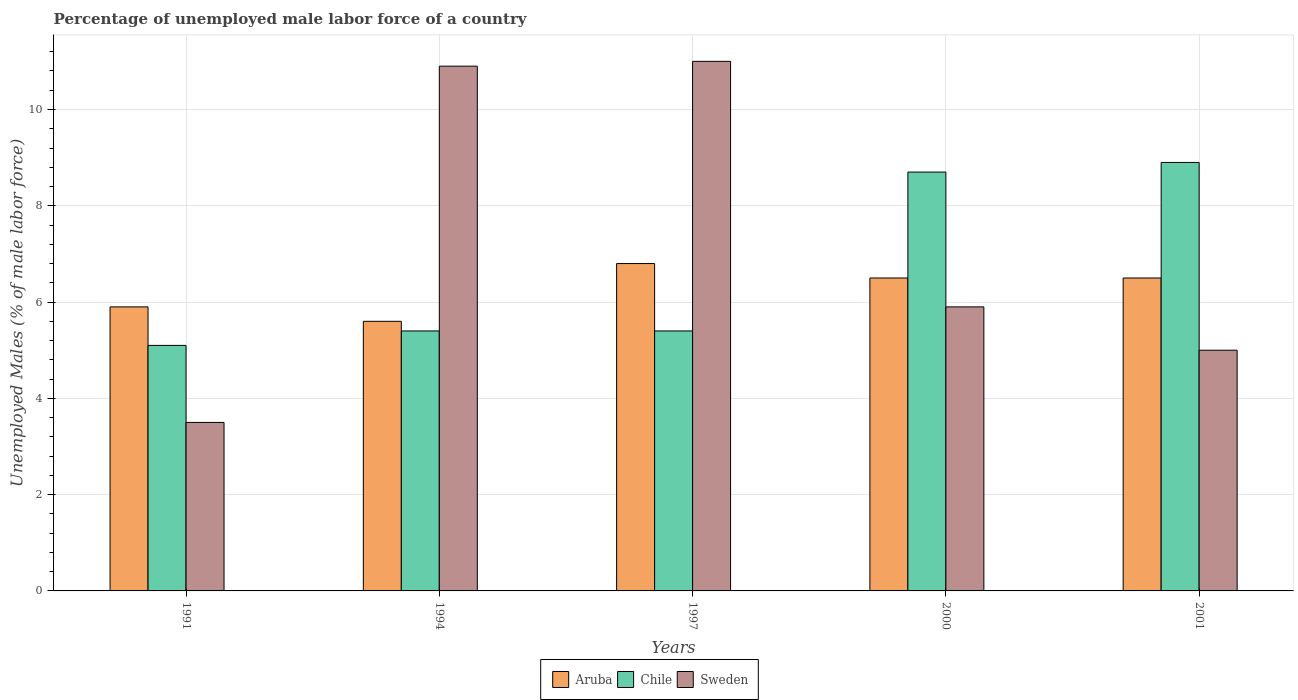How many different coloured bars are there?
Provide a succinct answer. 3. How many groups of bars are there?
Give a very brief answer. 5. Are the number of bars per tick equal to the number of legend labels?
Offer a terse response. Yes. How many bars are there on the 1st tick from the right?
Keep it short and to the point. 3. What is the percentage of unemployed male labor force in Chile in 2000?
Ensure brevity in your answer.  8.7. Across all years, what is the maximum percentage of unemployed male labor force in Sweden?
Your answer should be compact. 11. Across all years, what is the minimum percentage of unemployed male labor force in Chile?
Give a very brief answer. 5.1. What is the total percentage of unemployed male labor force in Aruba in the graph?
Provide a succinct answer. 31.3. What is the difference between the percentage of unemployed male labor force in Aruba in 1997 and that in 2001?
Your response must be concise. 0.3. What is the difference between the percentage of unemployed male labor force in Aruba in 1997 and the percentage of unemployed male labor force in Sweden in 1994?
Offer a very short reply. -4.1. What is the average percentage of unemployed male labor force in Aruba per year?
Offer a terse response. 6.26. In the year 2001, what is the difference between the percentage of unemployed male labor force in Aruba and percentage of unemployed male labor force in Chile?
Provide a short and direct response. -2.4. What is the ratio of the percentage of unemployed male labor force in Chile in 1991 to that in 1994?
Offer a very short reply. 0.94. Is the percentage of unemployed male labor force in Aruba in 1994 less than that in 2000?
Your response must be concise. Yes. Is the difference between the percentage of unemployed male labor force in Aruba in 1991 and 1994 greater than the difference between the percentage of unemployed male labor force in Chile in 1991 and 1994?
Make the answer very short. Yes. What is the difference between the highest and the second highest percentage of unemployed male labor force in Aruba?
Keep it short and to the point. 0.3. What is the difference between the highest and the lowest percentage of unemployed male labor force in Aruba?
Your response must be concise. 1.2. What does the 1st bar from the left in 1994 represents?
Provide a short and direct response. Aruba. What does the 3rd bar from the right in 1991 represents?
Your answer should be very brief. Aruba. Does the graph contain any zero values?
Offer a terse response. No. Where does the legend appear in the graph?
Your response must be concise. Bottom center. How many legend labels are there?
Offer a terse response. 3. What is the title of the graph?
Make the answer very short. Percentage of unemployed male labor force of a country. Does "Lower middle income" appear as one of the legend labels in the graph?
Make the answer very short. No. What is the label or title of the Y-axis?
Your answer should be compact. Unemployed Males (% of male labor force). What is the Unemployed Males (% of male labor force) of Aruba in 1991?
Make the answer very short. 5.9. What is the Unemployed Males (% of male labor force) of Chile in 1991?
Ensure brevity in your answer.  5.1. What is the Unemployed Males (% of male labor force) of Aruba in 1994?
Keep it short and to the point. 5.6. What is the Unemployed Males (% of male labor force) in Chile in 1994?
Provide a succinct answer. 5.4. What is the Unemployed Males (% of male labor force) of Sweden in 1994?
Your answer should be very brief. 10.9. What is the Unemployed Males (% of male labor force) in Aruba in 1997?
Ensure brevity in your answer.  6.8. What is the Unemployed Males (% of male labor force) of Chile in 1997?
Provide a short and direct response. 5.4. What is the Unemployed Males (% of male labor force) of Aruba in 2000?
Your response must be concise. 6.5. What is the Unemployed Males (% of male labor force) of Chile in 2000?
Offer a very short reply. 8.7. What is the Unemployed Males (% of male labor force) of Sweden in 2000?
Offer a very short reply. 5.9. What is the Unemployed Males (% of male labor force) of Chile in 2001?
Provide a short and direct response. 8.9. Across all years, what is the maximum Unemployed Males (% of male labor force) of Aruba?
Your answer should be compact. 6.8. Across all years, what is the maximum Unemployed Males (% of male labor force) of Chile?
Your answer should be very brief. 8.9. Across all years, what is the maximum Unemployed Males (% of male labor force) in Sweden?
Offer a terse response. 11. Across all years, what is the minimum Unemployed Males (% of male labor force) of Aruba?
Offer a terse response. 5.6. Across all years, what is the minimum Unemployed Males (% of male labor force) in Chile?
Your answer should be compact. 5.1. Across all years, what is the minimum Unemployed Males (% of male labor force) of Sweden?
Make the answer very short. 3.5. What is the total Unemployed Males (% of male labor force) of Aruba in the graph?
Your answer should be very brief. 31.3. What is the total Unemployed Males (% of male labor force) in Chile in the graph?
Make the answer very short. 33.5. What is the total Unemployed Males (% of male labor force) of Sweden in the graph?
Your answer should be very brief. 36.3. What is the difference between the Unemployed Males (% of male labor force) of Aruba in 1991 and that in 1994?
Your response must be concise. 0.3. What is the difference between the Unemployed Males (% of male labor force) in Chile in 1991 and that in 1994?
Provide a succinct answer. -0.3. What is the difference between the Unemployed Males (% of male labor force) of Sweden in 1991 and that in 1994?
Offer a very short reply. -7.4. What is the difference between the Unemployed Males (% of male labor force) of Sweden in 1991 and that in 1997?
Your response must be concise. -7.5. What is the difference between the Unemployed Males (% of male labor force) in Chile in 1991 and that in 2000?
Your answer should be very brief. -3.6. What is the difference between the Unemployed Males (% of male labor force) in Sweden in 1991 and that in 2000?
Ensure brevity in your answer.  -2.4. What is the difference between the Unemployed Males (% of male labor force) of Aruba in 1994 and that in 1997?
Offer a very short reply. -1.2. What is the difference between the Unemployed Males (% of male labor force) of Chile in 1994 and that in 2000?
Give a very brief answer. -3.3. What is the difference between the Unemployed Males (% of male labor force) in Sweden in 1994 and that in 2000?
Offer a terse response. 5. What is the difference between the Unemployed Males (% of male labor force) in Aruba in 1994 and that in 2001?
Provide a succinct answer. -0.9. What is the difference between the Unemployed Males (% of male labor force) of Chile in 1994 and that in 2001?
Ensure brevity in your answer.  -3.5. What is the difference between the Unemployed Males (% of male labor force) in Sweden in 1994 and that in 2001?
Make the answer very short. 5.9. What is the difference between the Unemployed Males (% of male labor force) in Chile in 1997 and that in 2000?
Ensure brevity in your answer.  -3.3. What is the difference between the Unemployed Males (% of male labor force) of Sweden in 1997 and that in 2000?
Your response must be concise. 5.1. What is the difference between the Unemployed Males (% of male labor force) in Aruba in 1997 and that in 2001?
Provide a succinct answer. 0.3. What is the difference between the Unemployed Males (% of male labor force) of Chile in 1997 and that in 2001?
Offer a terse response. -3.5. What is the difference between the Unemployed Males (% of male labor force) of Sweden in 1997 and that in 2001?
Provide a succinct answer. 6. What is the difference between the Unemployed Males (% of male labor force) of Aruba in 2000 and that in 2001?
Your answer should be compact. 0. What is the difference between the Unemployed Males (% of male labor force) in Aruba in 1991 and the Unemployed Males (% of male labor force) in Sweden in 1994?
Provide a succinct answer. -5. What is the difference between the Unemployed Males (% of male labor force) of Chile in 1991 and the Unemployed Males (% of male labor force) of Sweden in 1994?
Provide a succinct answer. -5.8. What is the difference between the Unemployed Males (% of male labor force) in Aruba in 1991 and the Unemployed Males (% of male labor force) in Chile in 1997?
Offer a very short reply. 0.5. What is the difference between the Unemployed Males (% of male labor force) of Chile in 1991 and the Unemployed Males (% of male labor force) of Sweden in 1997?
Your answer should be compact. -5.9. What is the difference between the Unemployed Males (% of male labor force) in Aruba in 1991 and the Unemployed Males (% of male labor force) in Sweden in 2001?
Provide a succinct answer. 0.9. What is the difference between the Unemployed Males (% of male labor force) of Chile in 1991 and the Unemployed Males (% of male labor force) of Sweden in 2001?
Provide a succinct answer. 0.1. What is the difference between the Unemployed Males (% of male labor force) in Aruba in 1994 and the Unemployed Males (% of male labor force) in Chile in 1997?
Keep it short and to the point. 0.2. What is the difference between the Unemployed Males (% of male labor force) in Aruba in 1994 and the Unemployed Males (% of male labor force) in Sweden in 1997?
Make the answer very short. -5.4. What is the difference between the Unemployed Males (% of male labor force) in Chile in 1994 and the Unemployed Males (% of male labor force) in Sweden in 1997?
Offer a very short reply. -5.6. What is the difference between the Unemployed Males (% of male labor force) of Aruba in 1994 and the Unemployed Males (% of male labor force) of Chile in 2000?
Your answer should be very brief. -3.1. What is the difference between the Unemployed Males (% of male labor force) of Chile in 1994 and the Unemployed Males (% of male labor force) of Sweden in 2000?
Ensure brevity in your answer.  -0.5. What is the difference between the Unemployed Males (% of male labor force) in Aruba in 1994 and the Unemployed Males (% of male labor force) in Chile in 2001?
Ensure brevity in your answer.  -3.3. What is the difference between the Unemployed Males (% of male labor force) of Chile in 1994 and the Unemployed Males (% of male labor force) of Sweden in 2001?
Offer a very short reply. 0.4. What is the difference between the Unemployed Males (% of male labor force) in Aruba in 1997 and the Unemployed Males (% of male labor force) in Sweden in 2000?
Offer a very short reply. 0.9. What is the difference between the Unemployed Males (% of male labor force) of Aruba in 1997 and the Unemployed Males (% of male labor force) of Sweden in 2001?
Your answer should be compact. 1.8. What is the difference between the Unemployed Males (% of male labor force) in Aruba in 2000 and the Unemployed Males (% of male labor force) in Chile in 2001?
Ensure brevity in your answer.  -2.4. What is the difference between the Unemployed Males (% of male labor force) of Aruba in 2000 and the Unemployed Males (% of male labor force) of Sweden in 2001?
Your answer should be very brief. 1.5. What is the difference between the Unemployed Males (% of male labor force) of Chile in 2000 and the Unemployed Males (% of male labor force) of Sweden in 2001?
Provide a succinct answer. 3.7. What is the average Unemployed Males (% of male labor force) in Aruba per year?
Offer a terse response. 6.26. What is the average Unemployed Males (% of male labor force) of Chile per year?
Your response must be concise. 6.7. What is the average Unemployed Males (% of male labor force) in Sweden per year?
Make the answer very short. 7.26. In the year 1991, what is the difference between the Unemployed Males (% of male labor force) in Aruba and Unemployed Males (% of male labor force) in Sweden?
Offer a very short reply. 2.4. In the year 1994, what is the difference between the Unemployed Males (% of male labor force) in Aruba and Unemployed Males (% of male labor force) in Sweden?
Provide a succinct answer. -5.3. In the year 1997, what is the difference between the Unemployed Males (% of male labor force) in Aruba and Unemployed Males (% of male labor force) in Sweden?
Offer a terse response. -4.2. In the year 2000, what is the difference between the Unemployed Males (% of male labor force) in Aruba and Unemployed Males (% of male labor force) in Sweden?
Provide a short and direct response. 0.6. In the year 2000, what is the difference between the Unemployed Males (% of male labor force) in Chile and Unemployed Males (% of male labor force) in Sweden?
Provide a short and direct response. 2.8. In the year 2001, what is the difference between the Unemployed Males (% of male labor force) in Aruba and Unemployed Males (% of male labor force) in Chile?
Your response must be concise. -2.4. In the year 2001, what is the difference between the Unemployed Males (% of male labor force) of Aruba and Unemployed Males (% of male labor force) of Sweden?
Provide a short and direct response. 1.5. What is the ratio of the Unemployed Males (% of male labor force) in Aruba in 1991 to that in 1994?
Your response must be concise. 1.05. What is the ratio of the Unemployed Males (% of male labor force) in Sweden in 1991 to that in 1994?
Provide a succinct answer. 0.32. What is the ratio of the Unemployed Males (% of male labor force) in Aruba in 1991 to that in 1997?
Give a very brief answer. 0.87. What is the ratio of the Unemployed Males (% of male labor force) in Sweden in 1991 to that in 1997?
Keep it short and to the point. 0.32. What is the ratio of the Unemployed Males (% of male labor force) of Aruba in 1991 to that in 2000?
Keep it short and to the point. 0.91. What is the ratio of the Unemployed Males (% of male labor force) in Chile in 1991 to that in 2000?
Ensure brevity in your answer.  0.59. What is the ratio of the Unemployed Males (% of male labor force) in Sweden in 1991 to that in 2000?
Your response must be concise. 0.59. What is the ratio of the Unemployed Males (% of male labor force) of Aruba in 1991 to that in 2001?
Provide a short and direct response. 0.91. What is the ratio of the Unemployed Males (% of male labor force) of Chile in 1991 to that in 2001?
Offer a very short reply. 0.57. What is the ratio of the Unemployed Males (% of male labor force) in Sweden in 1991 to that in 2001?
Give a very brief answer. 0.7. What is the ratio of the Unemployed Males (% of male labor force) of Aruba in 1994 to that in 1997?
Ensure brevity in your answer.  0.82. What is the ratio of the Unemployed Males (% of male labor force) in Sweden in 1994 to that in 1997?
Provide a short and direct response. 0.99. What is the ratio of the Unemployed Males (% of male labor force) in Aruba in 1994 to that in 2000?
Your response must be concise. 0.86. What is the ratio of the Unemployed Males (% of male labor force) of Chile in 1994 to that in 2000?
Ensure brevity in your answer.  0.62. What is the ratio of the Unemployed Males (% of male labor force) of Sweden in 1994 to that in 2000?
Give a very brief answer. 1.85. What is the ratio of the Unemployed Males (% of male labor force) of Aruba in 1994 to that in 2001?
Keep it short and to the point. 0.86. What is the ratio of the Unemployed Males (% of male labor force) of Chile in 1994 to that in 2001?
Provide a succinct answer. 0.61. What is the ratio of the Unemployed Males (% of male labor force) of Sweden in 1994 to that in 2001?
Offer a terse response. 2.18. What is the ratio of the Unemployed Males (% of male labor force) of Aruba in 1997 to that in 2000?
Give a very brief answer. 1.05. What is the ratio of the Unemployed Males (% of male labor force) of Chile in 1997 to that in 2000?
Ensure brevity in your answer.  0.62. What is the ratio of the Unemployed Males (% of male labor force) in Sweden in 1997 to that in 2000?
Offer a very short reply. 1.86. What is the ratio of the Unemployed Males (% of male labor force) of Aruba in 1997 to that in 2001?
Your answer should be compact. 1.05. What is the ratio of the Unemployed Males (% of male labor force) of Chile in 1997 to that in 2001?
Your response must be concise. 0.61. What is the ratio of the Unemployed Males (% of male labor force) in Sweden in 1997 to that in 2001?
Your response must be concise. 2.2. What is the ratio of the Unemployed Males (% of male labor force) of Aruba in 2000 to that in 2001?
Offer a very short reply. 1. What is the ratio of the Unemployed Males (% of male labor force) in Chile in 2000 to that in 2001?
Provide a short and direct response. 0.98. What is the ratio of the Unemployed Males (% of male labor force) in Sweden in 2000 to that in 2001?
Your response must be concise. 1.18. What is the difference between the highest and the lowest Unemployed Males (% of male labor force) in Aruba?
Your response must be concise. 1.2. What is the difference between the highest and the lowest Unemployed Males (% of male labor force) in Sweden?
Offer a terse response. 7.5. 